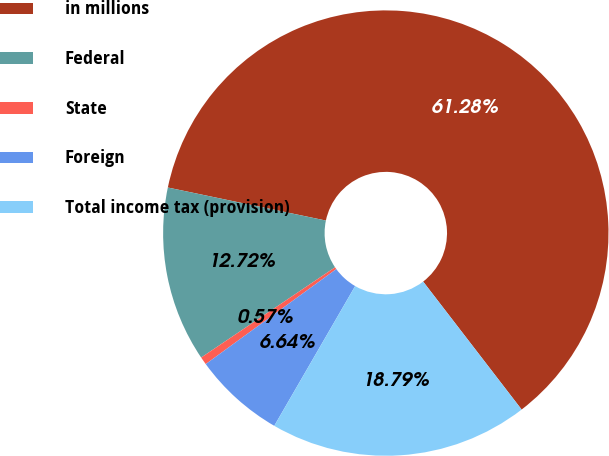Convert chart to OTSL. <chart><loc_0><loc_0><loc_500><loc_500><pie_chart><fcel>in millions<fcel>Federal<fcel>State<fcel>Foreign<fcel>Total income tax (provision)<nl><fcel>61.28%<fcel>12.72%<fcel>0.57%<fcel>6.64%<fcel>18.79%<nl></chart> 